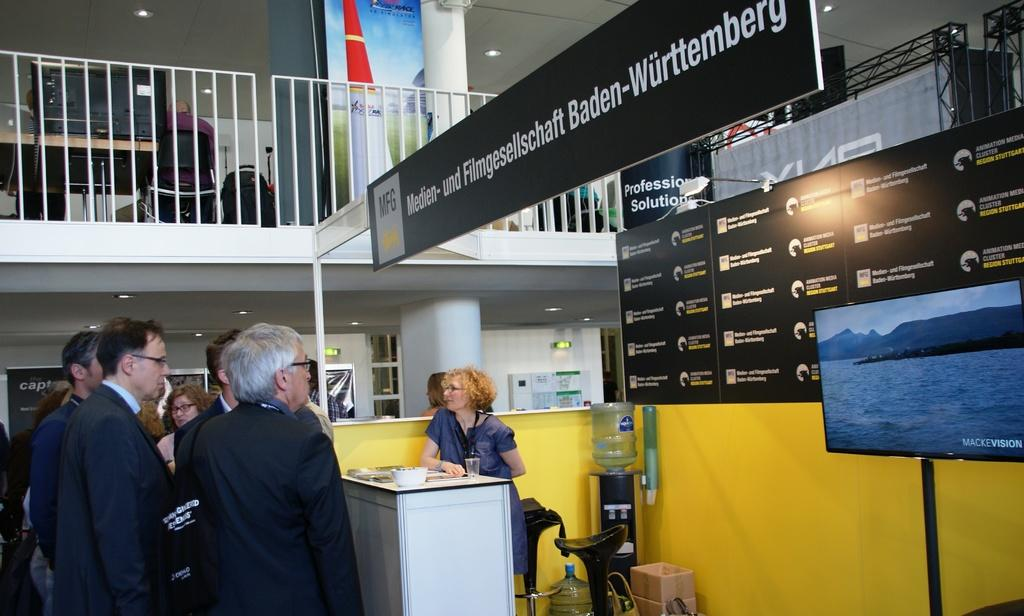Provide a one-sentence caption for the provided image. The men are crowding around a booth for the Fulmgesellscaft from Baden-Wurttemberg run my a middle aged woman with blonde curly hair. 